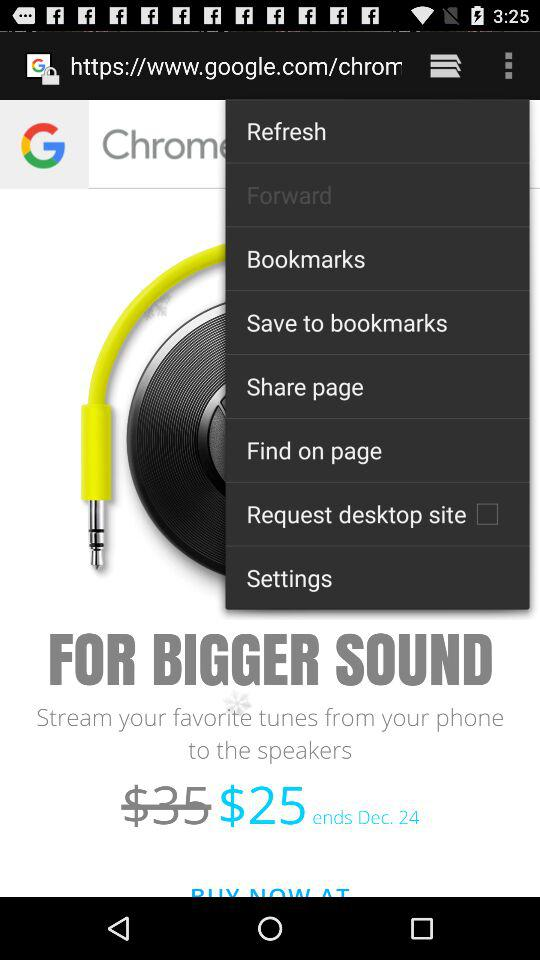How much is the price after the discount?
Answer the question using a single word or phrase. $25 